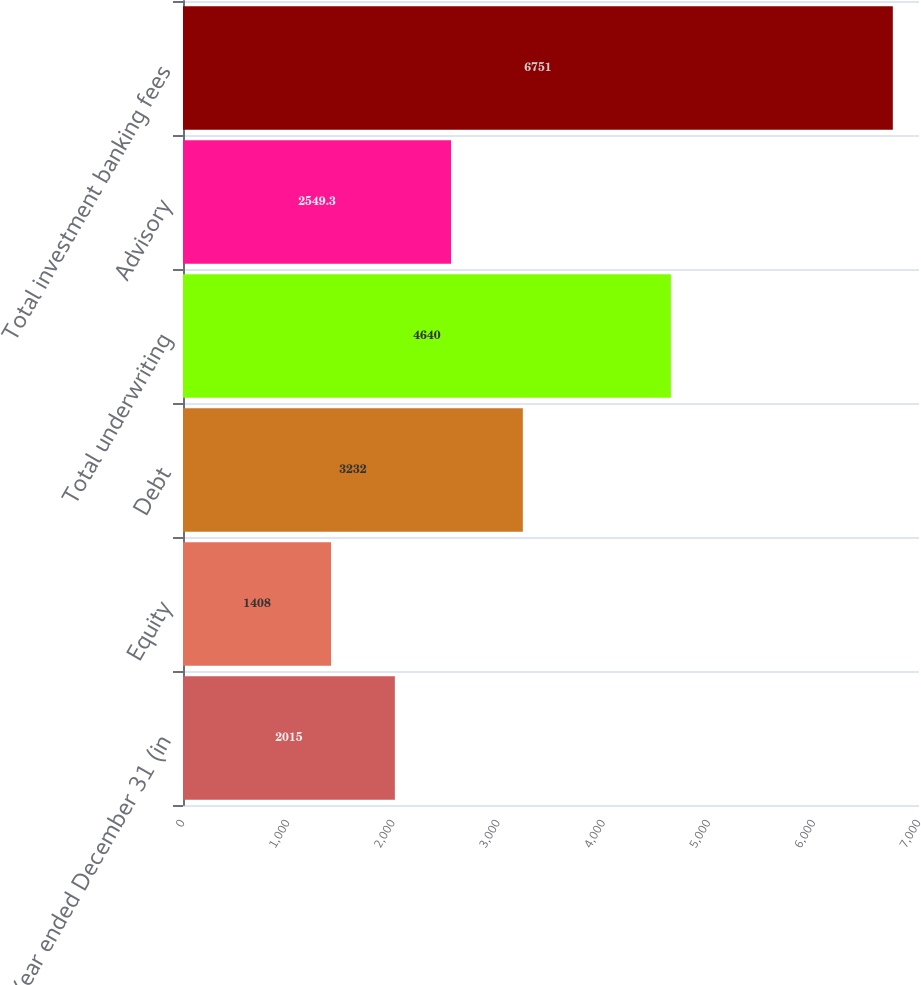Convert chart. <chart><loc_0><loc_0><loc_500><loc_500><bar_chart><fcel>Year ended December 31 (in<fcel>Equity<fcel>Debt<fcel>Total underwriting<fcel>Advisory<fcel>Total investment banking fees<nl><fcel>2015<fcel>1408<fcel>3232<fcel>4640<fcel>2549.3<fcel>6751<nl></chart> 